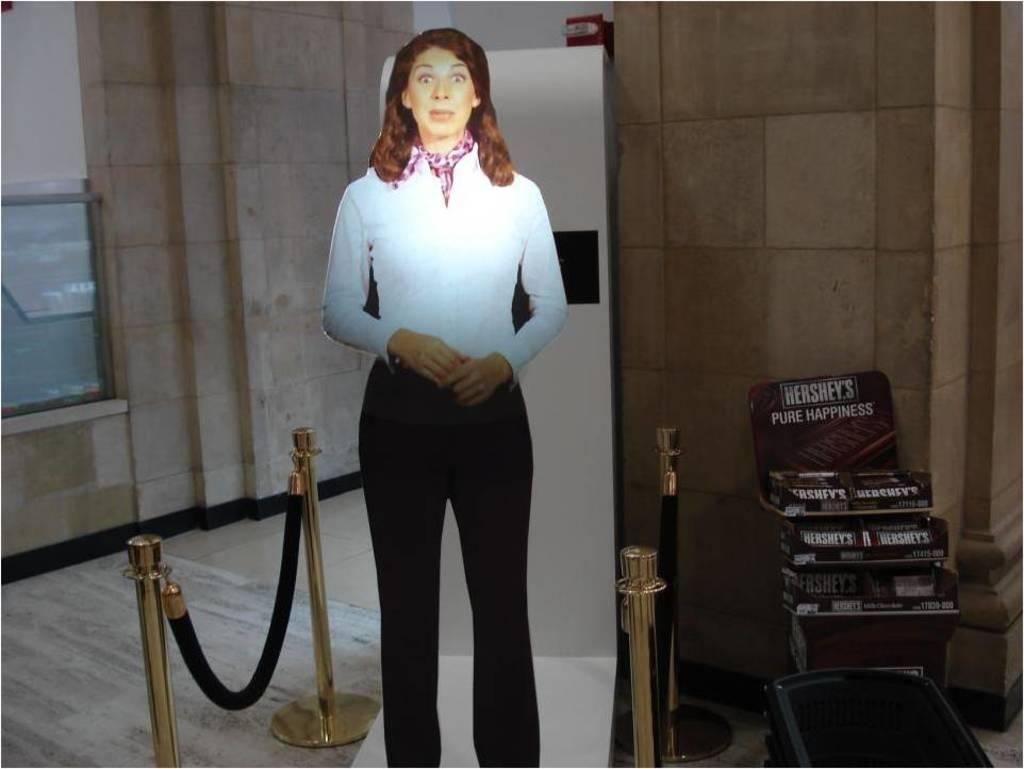<image>
Present a compact description of the photo's key features. A cardboard cutout of a surprised woman stands next to a display of Hershey's chocolate bars. 